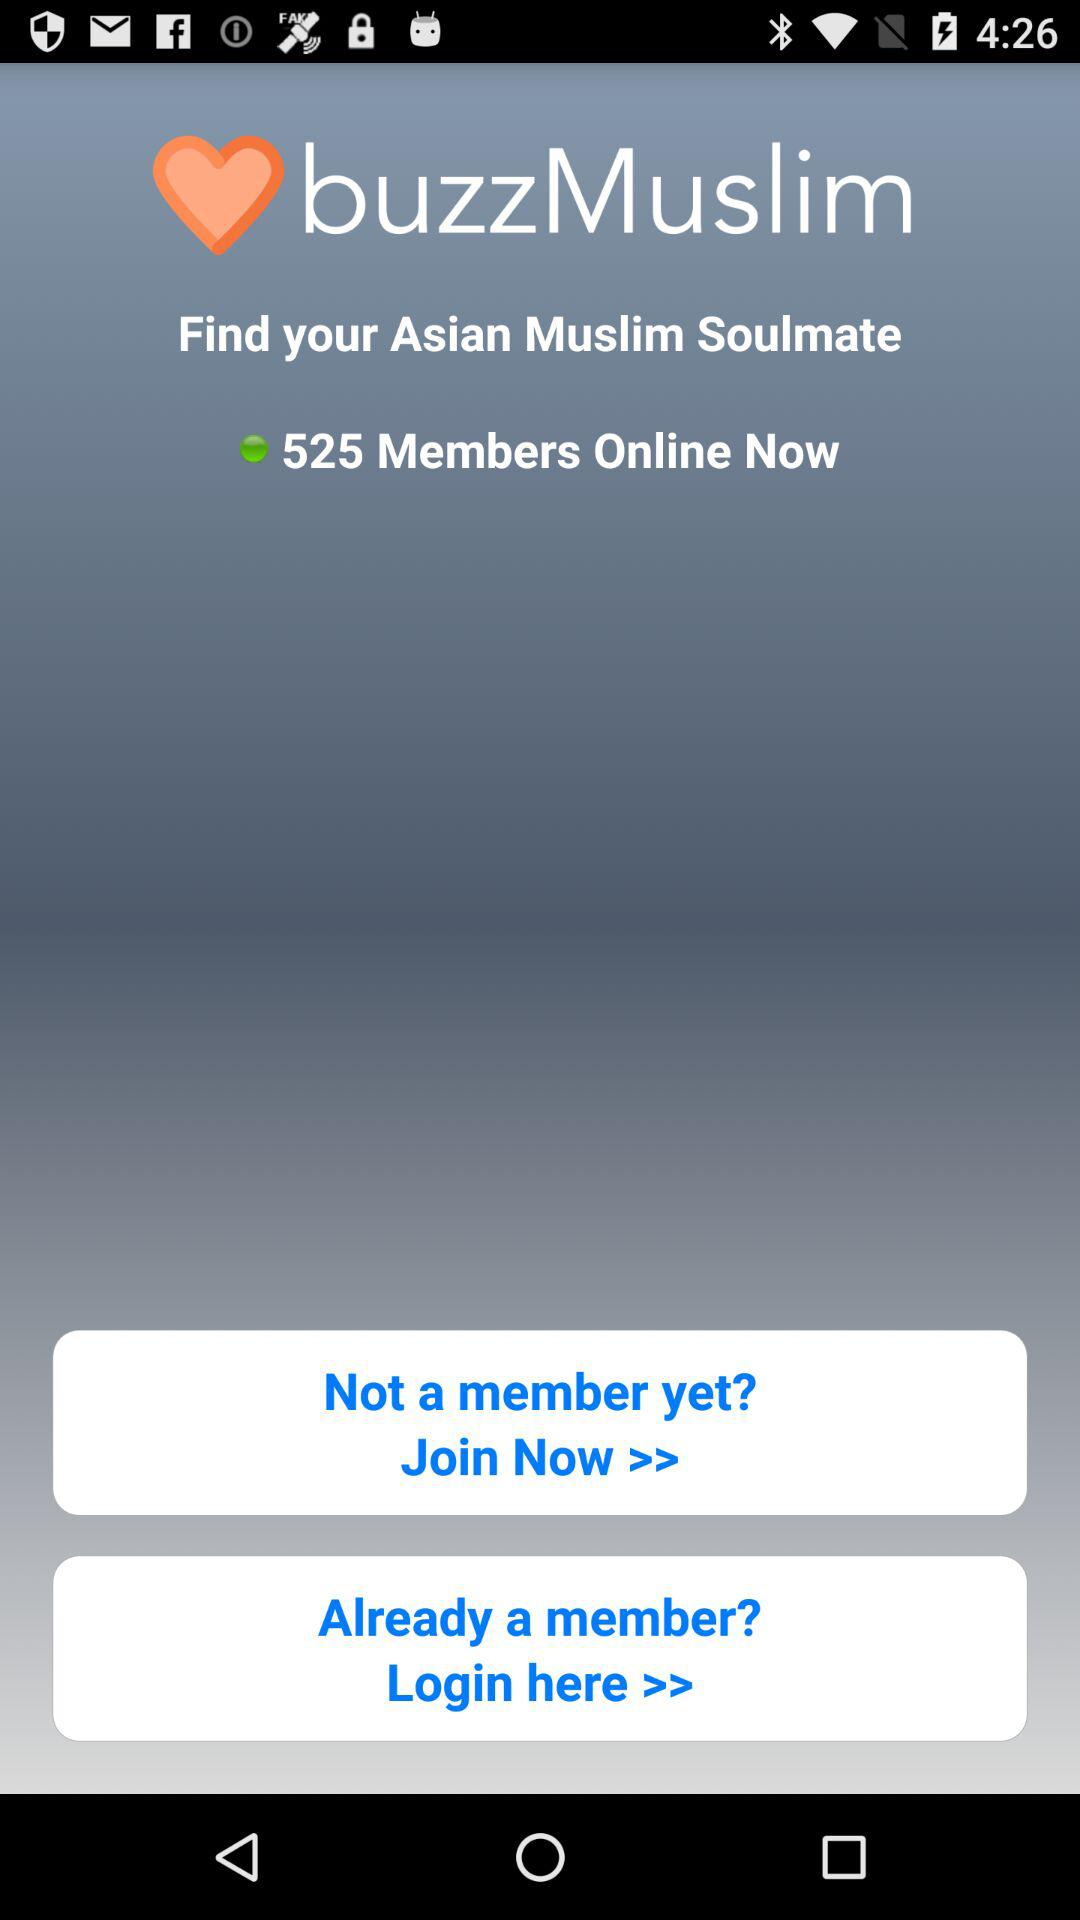What is the name of the application? The name of the application is "buzzMuslim". 